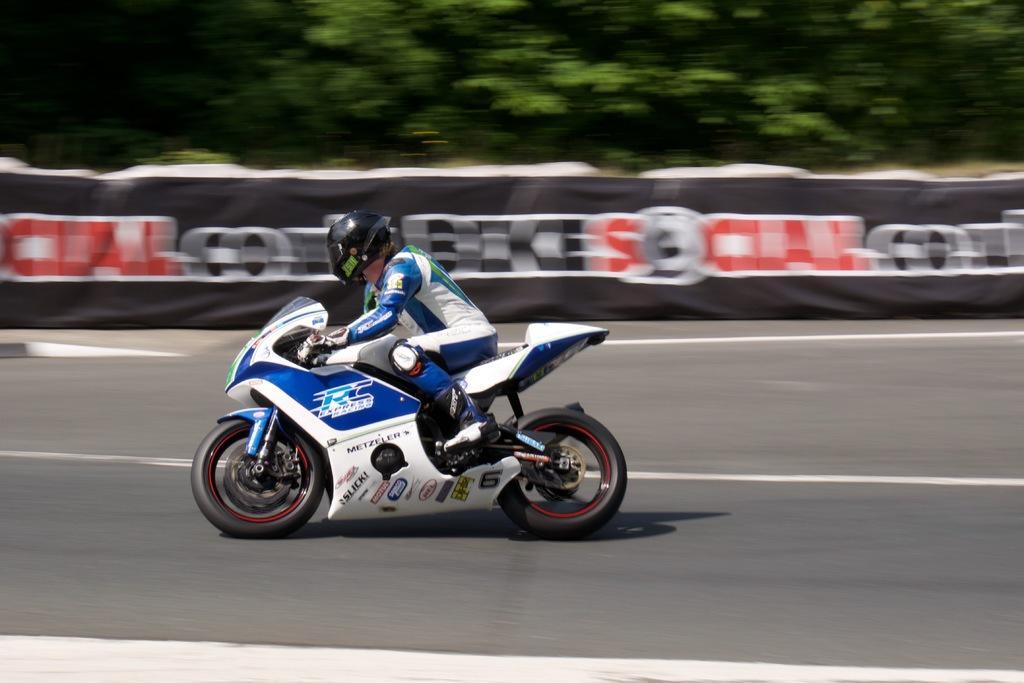Please provide a concise description of this image. In this image in the center there is a person riding a bike. In the background there is a banner with some text written on it and there are trees. 